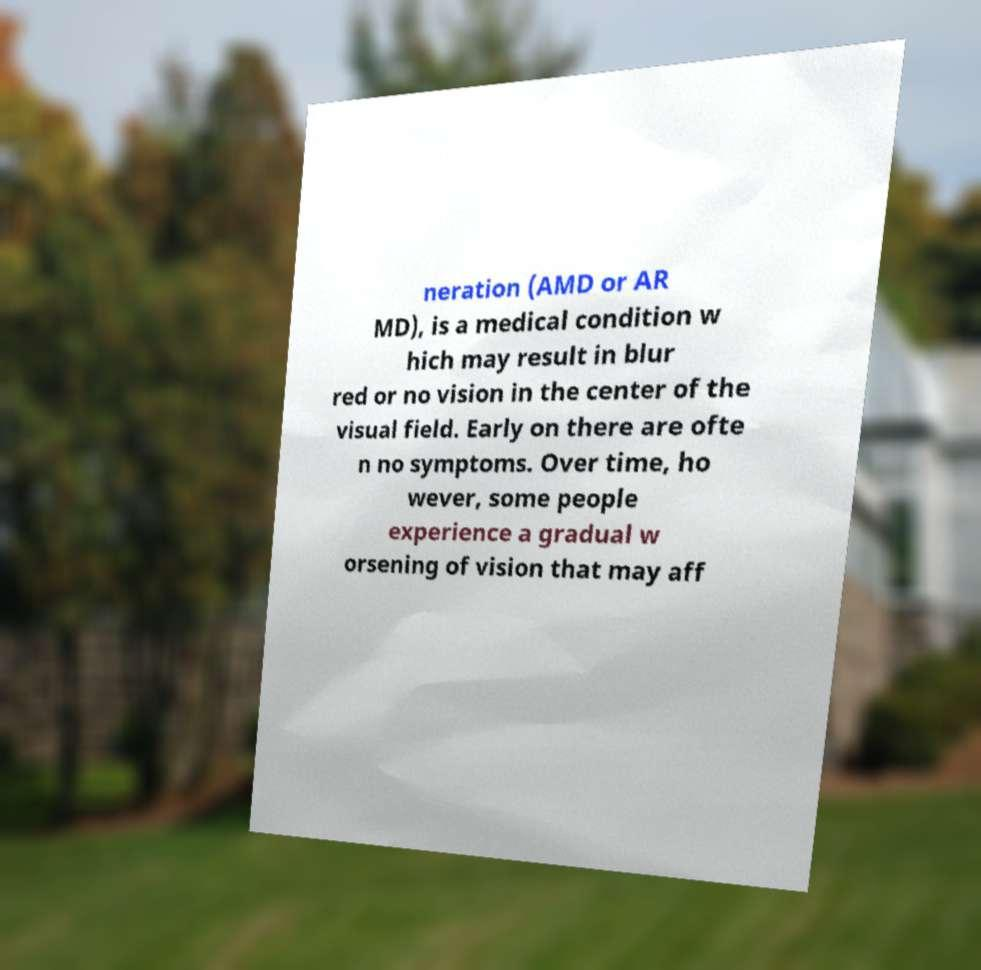Please read and relay the text visible in this image. What does it say? neration (AMD or AR MD), is a medical condition w hich may result in blur red or no vision in the center of the visual field. Early on there are ofte n no symptoms. Over time, ho wever, some people experience a gradual w orsening of vision that may aff 